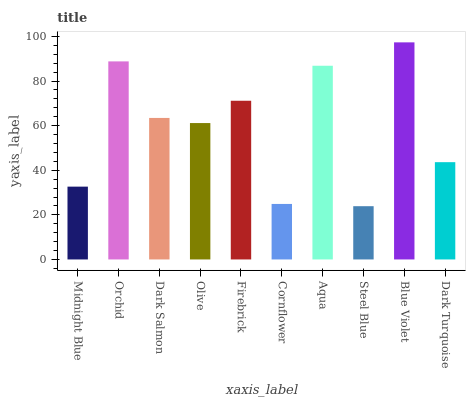Is Steel Blue the minimum?
Answer yes or no. Yes. Is Blue Violet the maximum?
Answer yes or no. Yes. Is Orchid the minimum?
Answer yes or no. No. Is Orchid the maximum?
Answer yes or no. No. Is Orchid greater than Midnight Blue?
Answer yes or no. Yes. Is Midnight Blue less than Orchid?
Answer yes or no. Yes. Is Midnight Blue greater than Orchid?
Answer yes or no. No. Is Orchid less than Midnight Blue?
Answer yes or no. No. Is Dark Salmon the high median?
Answer yes or no. Yes. Is Olive the low median?
Answer yes or no. Yes. Is Midnight Blue the high median?
Answer yes or no. No. Is Orchid the low median?
Answer yes or no. No. 